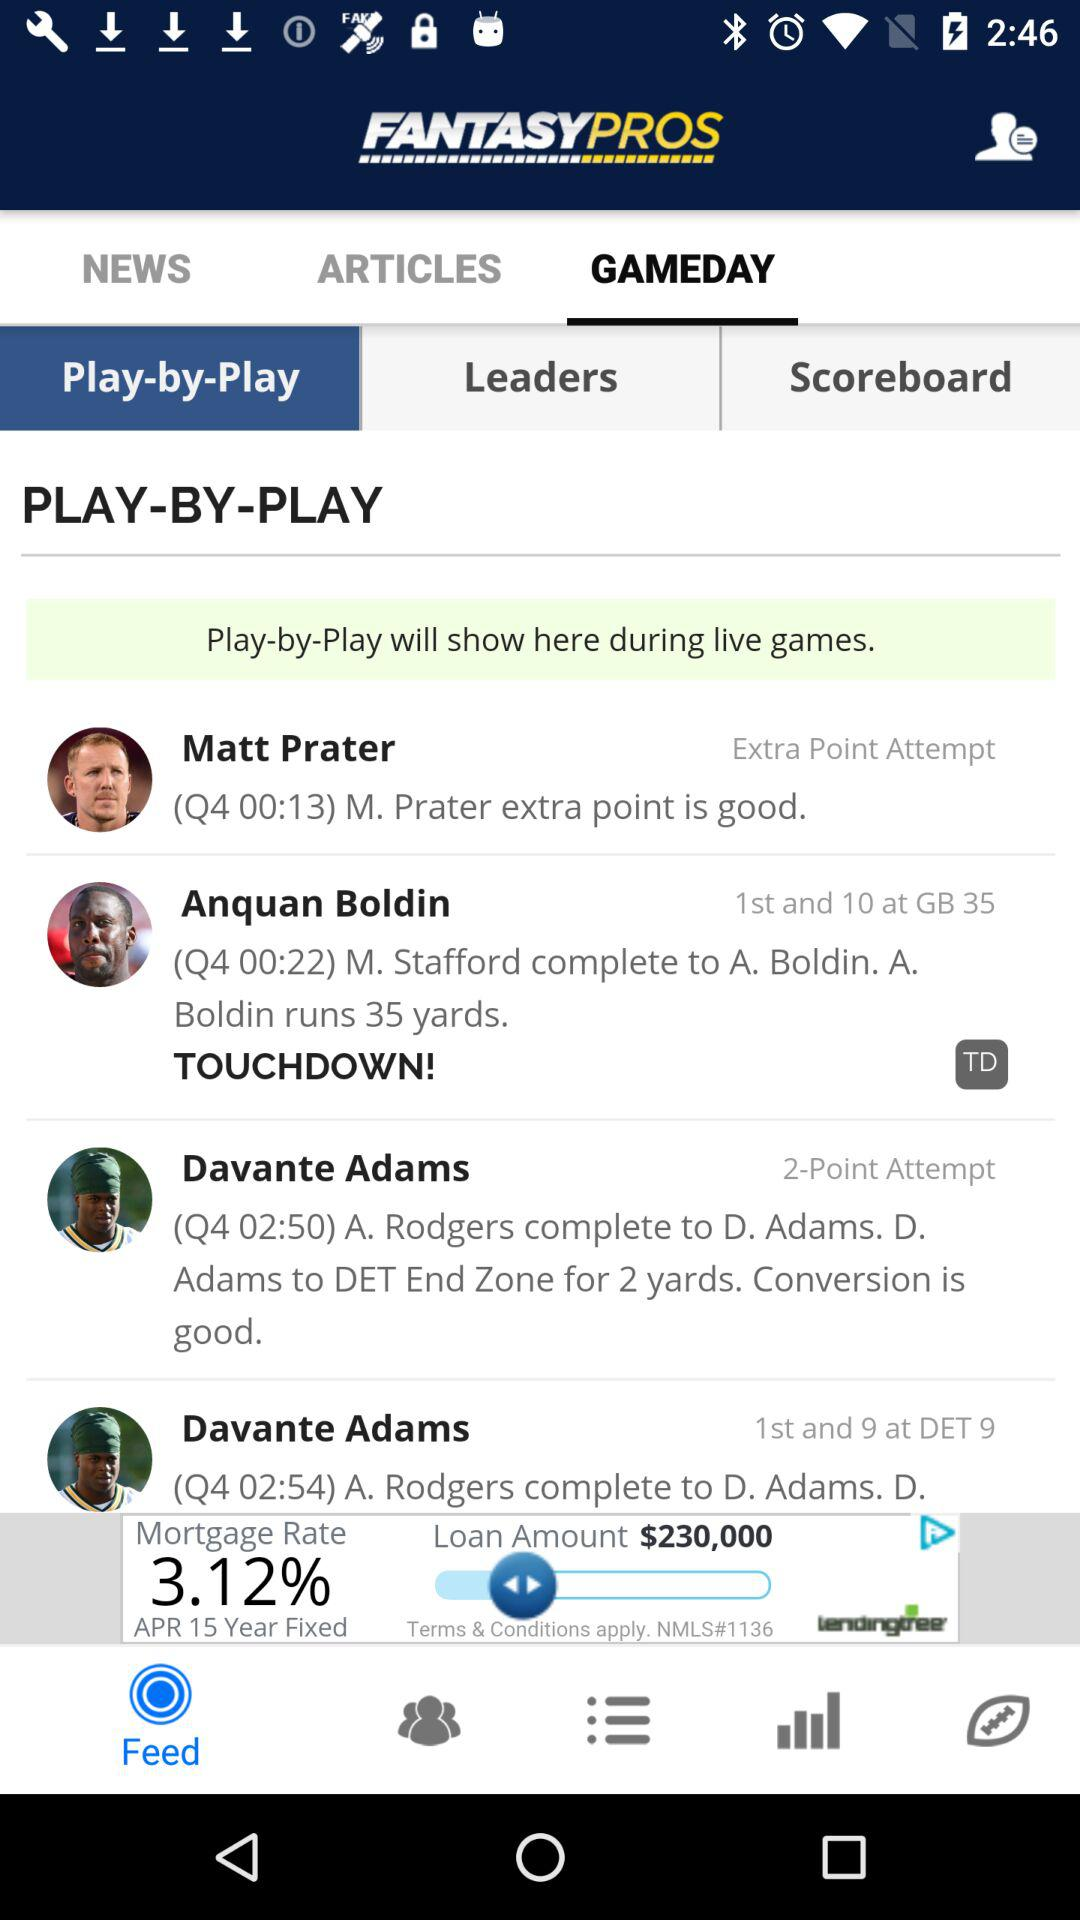How many more yards did Anquan Boldin run than Davante Adams?
Answer the question using a single word or phrase. 33 